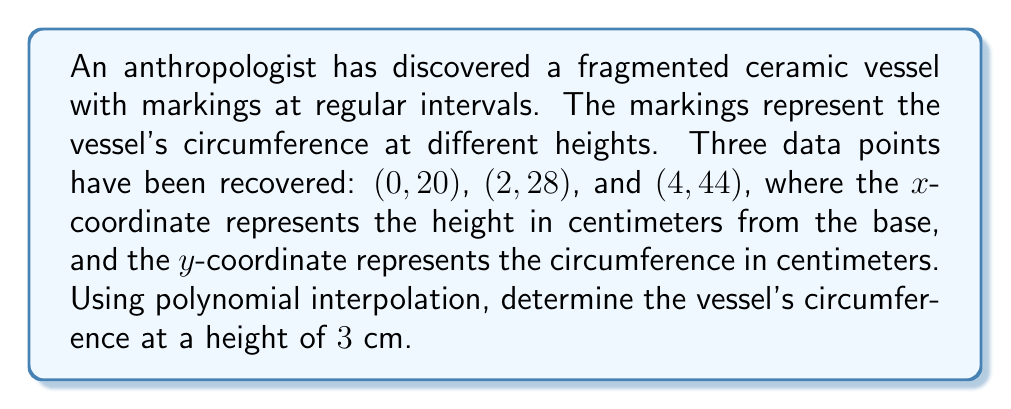Solve this math problem. To solve this problem, we'll use Lagrange polynomial interpolation. The steps are as follows:

1) The Lagrange interpolation polynomial is given by:
   $$P(x) = \sum_{i=1}^n y_i \cdot L_i(x)$$
   where $L_i(x)$ are the Lagrange basis polynomials.

2) For our three points, we have:
   $$L_1(x) = \frac{(x-2)(x-4)}{(0-2)(0-4)}$$
   $$L_2(x) = \frac{(x-0)(x-4)}{(2-0)(2-4)}$$
   $$L_3(x) = \frac{(x-0)(x-2)}{(4-0)(4-2)}$$

3) Simplifying:
   $$L_1(x) = \frac{x^2-6x+8}{8}$$
   $$L_2(x) = -\frac{x^2-4x}{4}$$
   $$L_3(x) = \frac{x^2-2x}{8}$$

4) Our interpolation polynomial is:
   $$P(x) = 20 \cdot \frac{x^2-6x+8}{8} + 28 \cdot (-\frac{x^2-4x}{4}) + 44 \cdot \frac{x^2-2x}{8}$$

5) Simplifying:
   $$P(x) = \frac{5x^2-15x+20}{2} - 7x^2+28x + \frac{11x^2-22x}{2}$$
   $$P(x) = \frac{5x^2-15x+20 - 14x^2+56x + 11x^2-22x}{2}$$
   $$P(x) = \frac{2x^2+19x+20}{2}$$
   $$P(x) = x^2+\frac{19}{2}x+10$$

6) To find the circumference at height 3 cm, we calculate P(3):
   $$P(3) = 3^2+\frac{19}{2}(3)+10 = 9+\frac{57}{2}+10 = \frac{85}{2} = 42.5$$

Therefore, the circumference of the vessel at a height of 3 cm is 42.5 cm.
Answer: 42.5 cm 